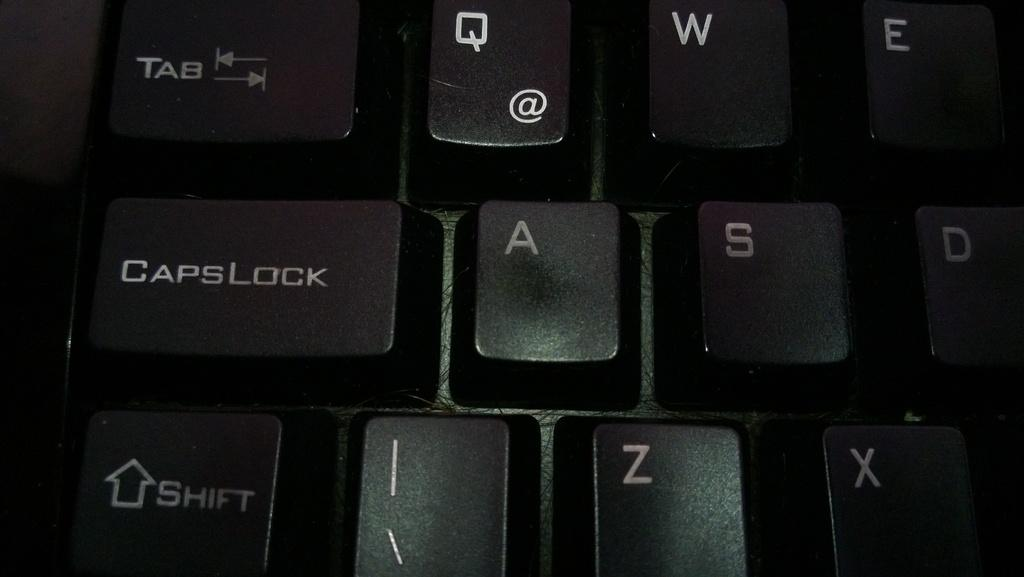<image>
Relay a brief, clear account of the picture shown. A computer keyboard with a caps lock key. 